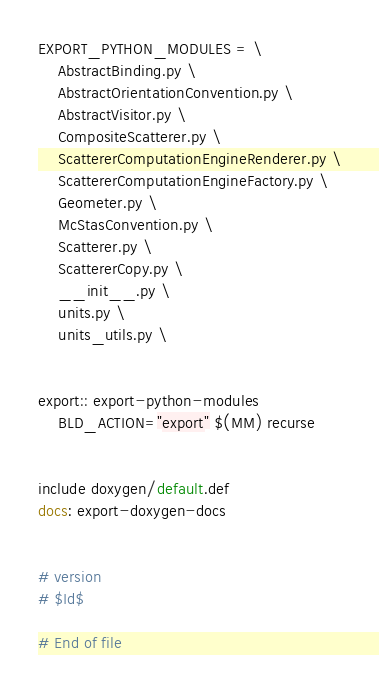<code> <loc_0><loc_0><loc_500><loc_500><_ObjectiveC_>
EXPORT_PYTHON_MODULES = \
	AbstractBinding.py \
	AbstractOrientationConvention.py \
	AbstractVisitor.py \
	CompositeScatterer.py \
	ScattererComputationEngineRenderer.py \
	ScattererComputationEngineFactory.py \
	Geometer.py \
	McStasConvention.py \
	Scatterer.py \
	ScattererCopy.py \
	__init__.py \
	units.py \
	units_utils.py \


export:: export-python-modules 
	BLD_ACTION="export" $(MM) recurse


include doxygen/default.def
docs: export-doxygen-docs


# version
# $Id$

# End of file
</code> 